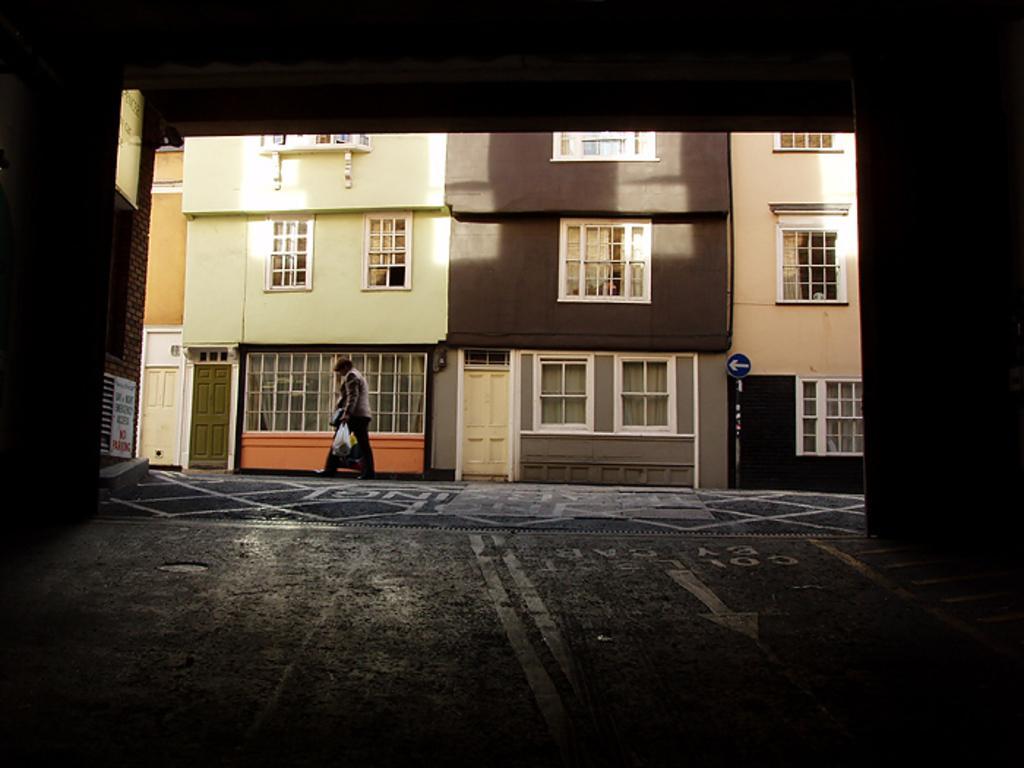Please provide a concise description of this image. In the middle of the image a man is walking. Behind him there is a building. Bottom right side of the image there is a pole and sign board. 